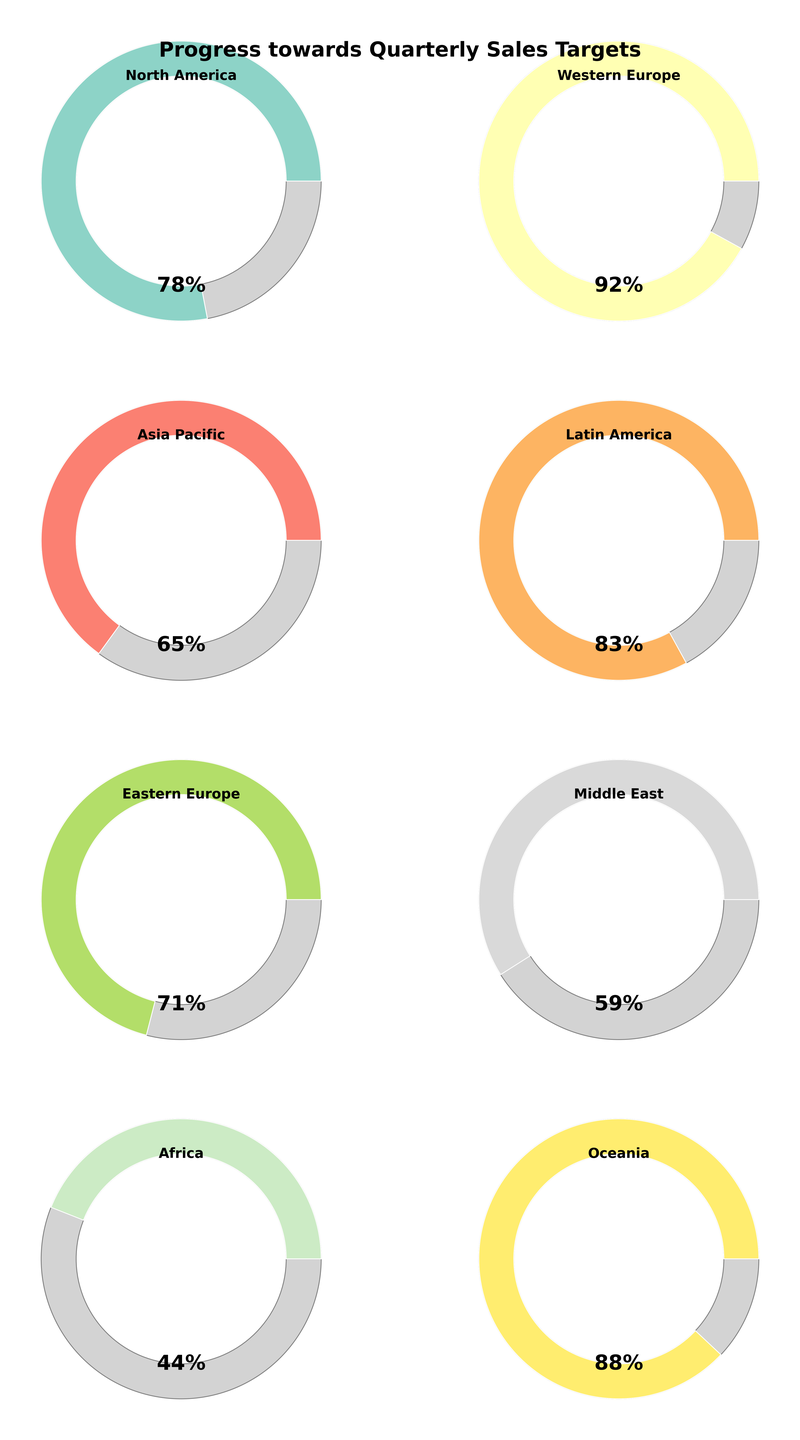Which region has the highest sales target percentage? By looking at the figure, the region with the highest sales target percentage can be identified by the gauge with the largest filled arc. Western Europe shows a higher percentage fill compared to other regions.
Answer: Western Europe What is the sales target percentage for the Middle East? The gauge for the Middle East indicates its sales target percentage directly. By referring to the label inside the Middle East gauge, it reads 59%.
Answer: 59% How many regions have achieved a sales target percentage above 80%? By counting the gauges with percentages above 80%, we find that there are four: Western Europe (92%), Oceania (88%), Latin America (83%), and North America (78%).
Answer: 3 Which regions have a lower sales target percentage than 70%? By examining the gauges, the regions with percentages lower than 70% are Asia Pacific (65%), Middle East (59%), and Africa (44%).
Answer: Asia Pacific, Middle East, Africa What is the average sales target percentage for Eastern Europe and Oceania? The percentages for Eastern Europe and Oceania are 71% and 88% respectively. The average is calculated as follows: (71 + 88) / 2 = 159 / 2 = 79.5.
Answer: 79.5 Compare the sales target percentage of Latin America to North America. Which is higher? By looking at the gauges, Latin America has a percentage of 83%, while North America has a percentage of 78%. Thus, Latin America's percentage is higher.
Answer: Latin America What is the median sales target percentage across all regions? The percentages are 92, 88, 83, 78, 71, 65, 59, 44. Arranging them in ascending order: 44, 59, 65, 71, 78, 83, 88, 92. The median value for an even number of data points is the average of the two middle numbers, (71 + 78) / 2 = 149 / 2 = 74.5.
Answer: 74.5 How much lower is Africa's sales target percentage compared to Asia Pacific? Asia Pacific has 65% and Africa has 44%. The difference is calculated as: 65 - 44 = 21.
Answer: 21 Which regions have a sales target percentage between 60% and 80% inclusive? By examining the gauges, the regions with percentages between 60% and 80% are North America (78%), Eastern Europe (71%), and Asia Pacific (65%).
Answer: North America, Eastern Europe, Asia Pacific Describe the layout of the subplots in the figure. The figure is arranged in a 4x2 grid, meaning there are 4 rows and 2 columns of gauge charts, providing a comprehensive view of all regions.
Answer: 4x2 grid 